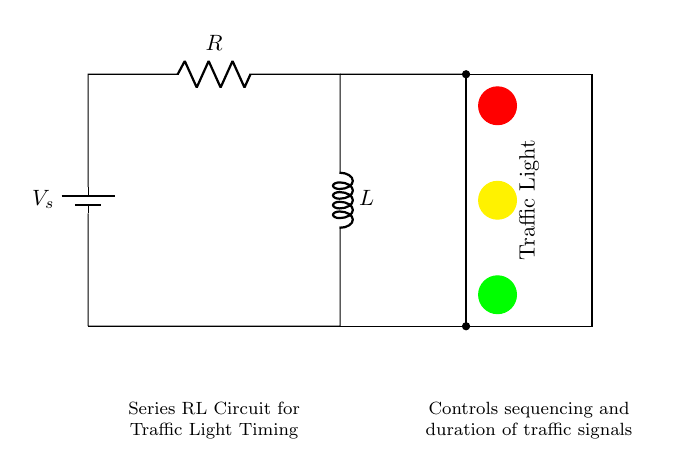What is the source voltage in this circuit? The voltage source is labeled as Vs in the diagram, indicating it is the supply voltage for the circuit.
Answer: Vs What components are present in this circuit? The diagram shows a resistor (labeled R) and an inductor (labeled L) in series along with a voltage source (Vs).
Answer: Resistor and Inductor What does the traffic light represent in this circuit? The traffic light visually illustrates the output of the circuit, indicating how the control system manages the sequencing of the traffic signals based on the timing defined by the RL circuit.
Answer: Traffic signal sequencing What is the function of the resistor in this circuit? The resistor in a series RL circuit limits the current flow and affects the time constant, which influences how quickly the circuit responds to changes in voltage.
Answer: Limits current flow How does the inductor affect the timing of the traffic lights? The inductor stores energy in a magnetic field and releases it gradually, thus affecting how long it takes for the current to change in response to the voltage. This time delay controls the traffic light timing.
Answer: Affects current change time What is the time constant of this circuit? The time constant is given by the product of resistance and inductance (tau = R * L). This value determines how quickly the circuit responds to changes in voltage, directly influencing the timing sequence of the traffic signals.
Answer: R times L What would happen if the resistance decreased? A decrease in resistance would result in an increase in current flow, causing the inductor to respond faster and ultimately lead to shorter timing intervals for the traffic lights.
Answer: Timing intervals would shorten 